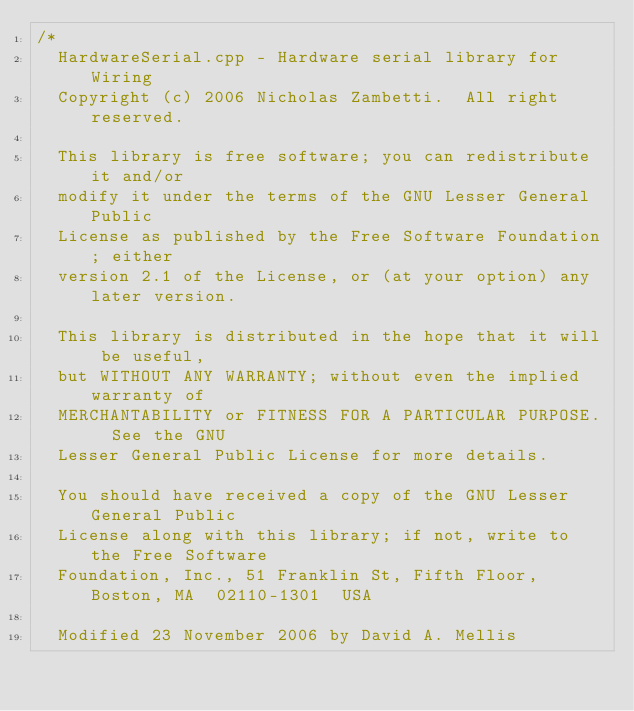Convert code to text. <code><loc_0><loc_0><loc_500><loc_500><_C++_>/*
  HardwareSerial.cpp - Hardware serial library for Wiring
  Copyright (c) 2006 Nicholas Zambetti.  All right reserved.

  This library is free software; you can redistribute it and/or
  modify it under the terms of the GNU Lesser General Public
  License as published by the Free Software Foundation; either
  version 2.1 of the License, or (at your option) any later version.

  This library is distributed in the hope that it will be useful,
  but WITHOUT ANY WARRANTY; without even the implied warranty of
  MERCHANTABILITY or FITNESS FOR A PARTICULAR PURPOSE.  See the GNU
  Lesser General Public License for more details.

  You should have received a copy of the GNU Lesser General Public
  License along with this library; if not, write to the Free Software
  Foundation, Inc., 51 Franklin St, Fifth Floor, Boston, MA  02110-1301  USA
  
  Modified 23 November 2006 by David A. Mellis</code> 